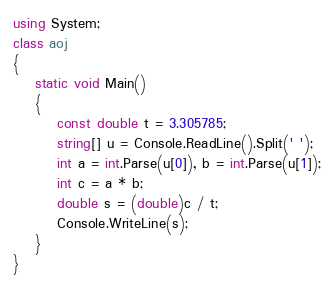Convert code to text. <code><loc_0><loc_0><loc_500><loc_500><_C#_>using System;
class aoj
{
    static void Main()
    {
        const double t = 3.305785;
        string[] u = Console.ReadLine().Split(' ');
        int a = int.Parse(u[0]), b = int.Parse(u[1]);
        int c = a * b;
        double s = (double)c / t;
        Console.WriteLine(s);
    }
}</code> 